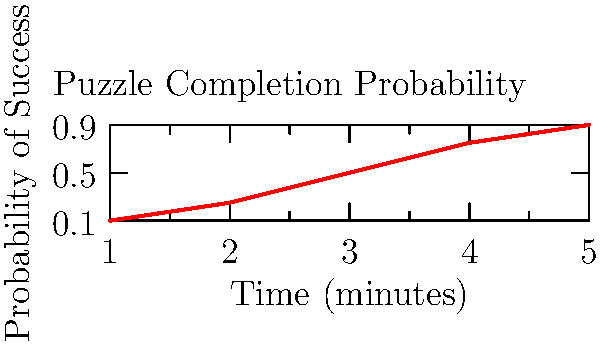In a probability-based puzzle game, players must arrange 10 uniquely shaped pieces to form a specific shape within a time limit. The graph shows the probability of successfully completing the puzzle based on the time given. If a player has a 75% chance of completing the puzzle, approximately how much time should be allotted? How would you calculate the exact time using interpolation? To solve this problem, we'll follow these steps:

1. Observe the graph: The y-axis represents the probability of success, and the x-axis represents time in minutes.

2. Locate the target probability: We're looking for a 75% (0.75) chance of success.

3. Estimate from the graph: The 0.75 probability line intersects the curve at approximately 4 minutes.

4. Calculate the exact time using linear interpolation:
   a. Identify the two closest known points:
      (3, 0.5) and (4, 0.75)
   b. Use the linear interpolation formula:
      $$t = t_1 + \frac{(p - p_1)(t_2 - t_1)}{p_2 - p_1}$$
      Where:
      $t$ is the time we're solving for
      $t_1 = 3$, $t_2 = 4$
      $p = 0.75$ (target probability)
      $p_1 = 0.5$, $p_2 = 0.75$

   c. Plug in the values:
      $$t = 3 + \frac{(0.75 - 0.5)(4 - 3)}{0.75 - 0.5} = 3 + \frac{0.25}{0.25} = 3 + 1 = 4$$

5. The exact time for a 75% chance of success is 4 minutes.

This calculation method can be used to determine precise time limits for different success probabilities, allowing for balanced and fair puzzle designs.
Answer: 4 minutes 